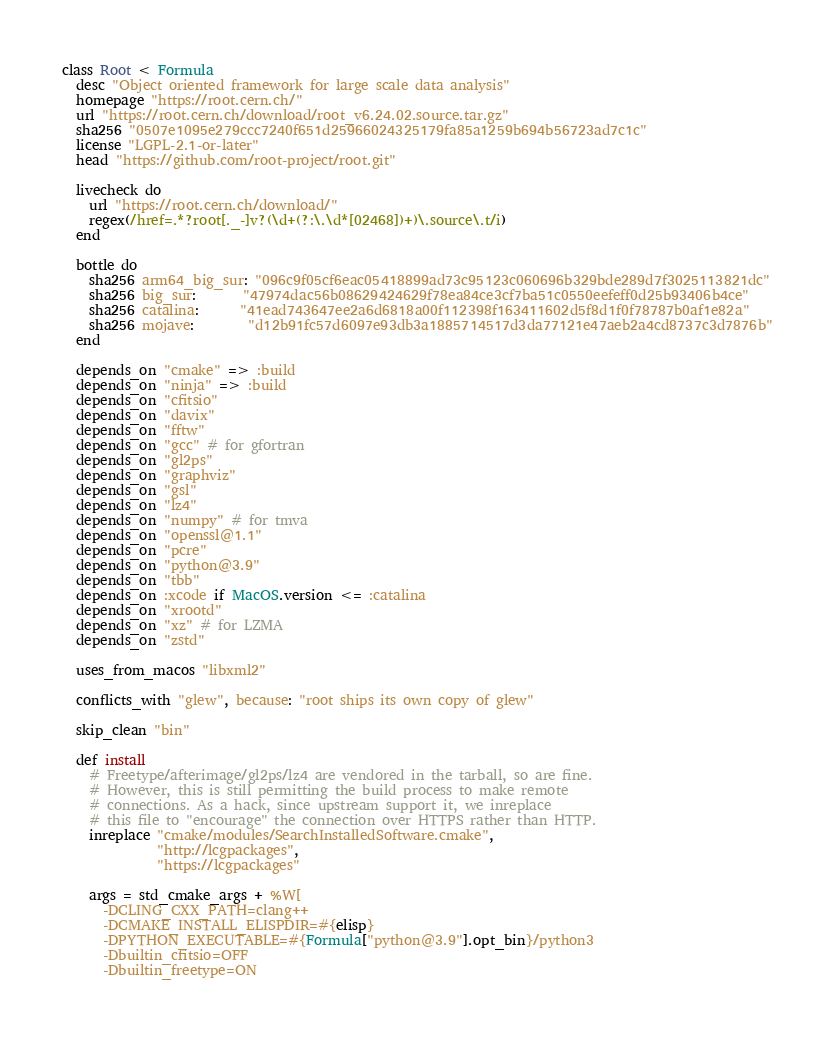<code> <loc_0><loc_0><loc_500><loc_500><_Ruby_>class Root < Formula
  desc "Object oriented framework for large scale data analysis"
  homepage "https://root.cern.ch/"
  url "https://root.cern.ch/download/root_v6.24.02.source.tar.gz"
  sha256 "0507e1095e279ccc7240f651d25966024325179fa85a1259b694b56723ad7c1c"
  license "LGPL-2.1-or-later"
  head "https://github.com/root-project/root.git"

  livecheck do
    url "https://root.cern.ch/download/"
    regex(/href=.*?root[._-]v?(\d+(?:\.\d*[02468])+)\.source\.t/i)
  end

  bottle do
    sha256 arm64_big_sur: "096c9f05cf6eac05418899ad73c95123c060696b329bde289d7f3025113821dc"
    sha256 big_sur:       "47974dac56b08629424629f78ea84ce3cf7ba51c0550eefeff0d25b93406b4ce"
    sha256 catalina:      "41ead743647ee2a6d6818a00f112398f163411602d5f8d1f0f78787b0af1e82a"
    sha256 mojave:        "d12b91fc57d6097e93db3a1885714517d3da77121e47aeb2a4cd8737c3d7876b"
  end

  depends_on "cmake" => :build
  depends_on "ninja" => :build
  depends_on "cfitsio"
  depends_on "davix"
  depends_on "fftw"
  depends_on "gcc" # for gfortran
  depends_on "gl2ps"
  depends_on "graphviz"
  depends_on "gsl"
  depends_on "lz4"
  depends_on "numpy" # for tmva
  depends_on "openssl@1.1"
  depends_on "pcre"
  depends_on "python@3.9"
  depends_on "tbb"
  depends_on :xcode if MacOS.version <= :catalina
  depends_on "xrootd"
  depends_on "xz" # for LZMA
  depends_on "zstd"

  uses_from_macos "libxml2"

  conflicts_with "glew", because: "root ships its own copy of glew"

  skip_clean "bin"

  def install
    # Freetype/afterimage/gl2ps/lz4 are vendored in the tarball, so are fine.
    # However, this is still permitting the build process to make remote
    # connections. As a hack, since upstream support it, we inreplace
    # this file to "encourage" the connection over HTTPS rather than HTTP.
    inreplace "cmake/modules/SearchInstalledSoftware.cmake",
              "http://lcgpackages",
              "https://lcgpackages"

    args = std_cmake_args + %W[
      -DCLING_CXX_PATH=clang++
      -DCMAKE_INSTALL_ELISPDIR=#{elisp}
      -DPYTHON_EXECUTABLE=#{Formula["python@3.9"].opt_bin}/python3
      -Dbuiltin_cfitsio=OFF
      -Dbuiltin_freetype=ON</code> 